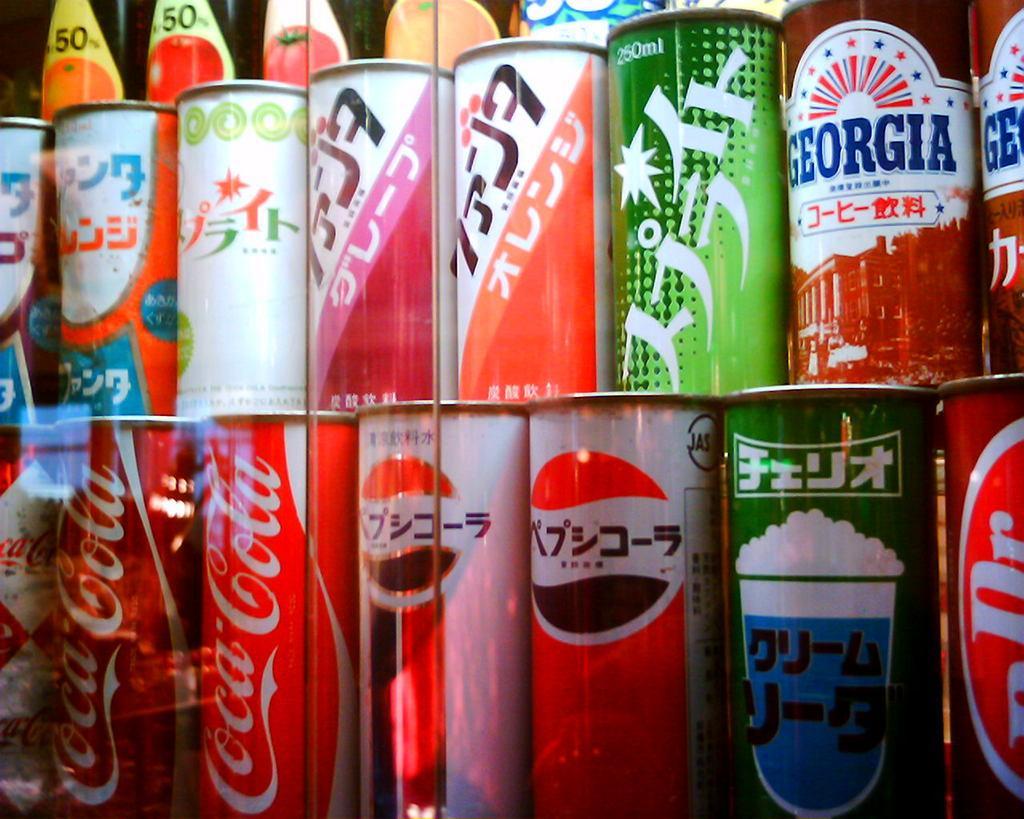Please provide a concise description of this image. In this image I can see few tins. They are in different color. Back I can few stickers attached to the bottles. 